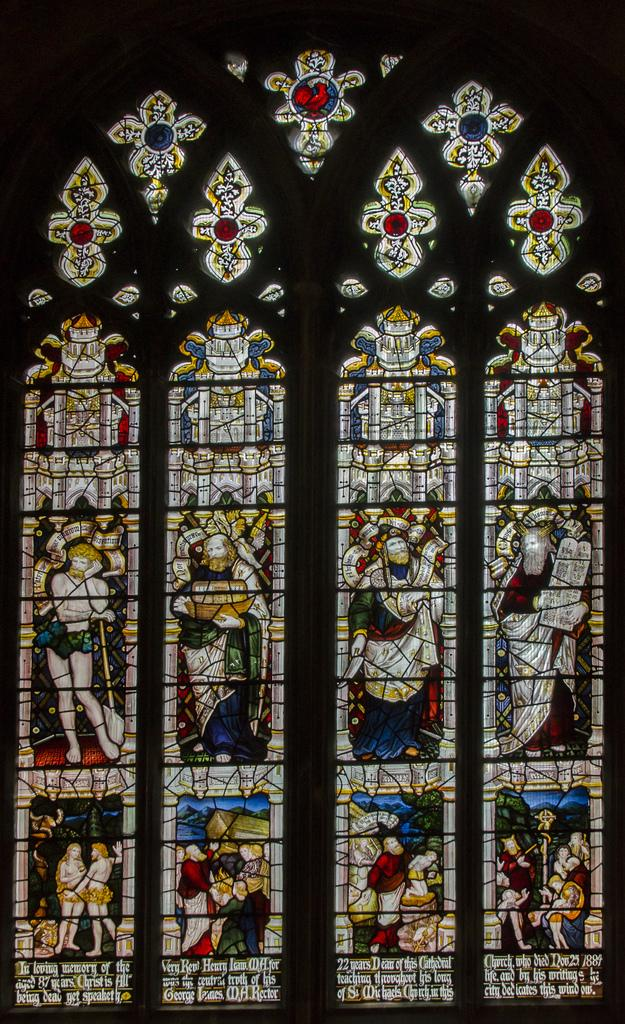What can be seen in the image that provides a view or access to the outdoors? There is a window in the image. What is special about the window in the image? The window has designer glass. Can you see a ghost in the image through the designer glass window? There is no ghost present in the image, and the designer glass window only provides a view of the outdoors. 